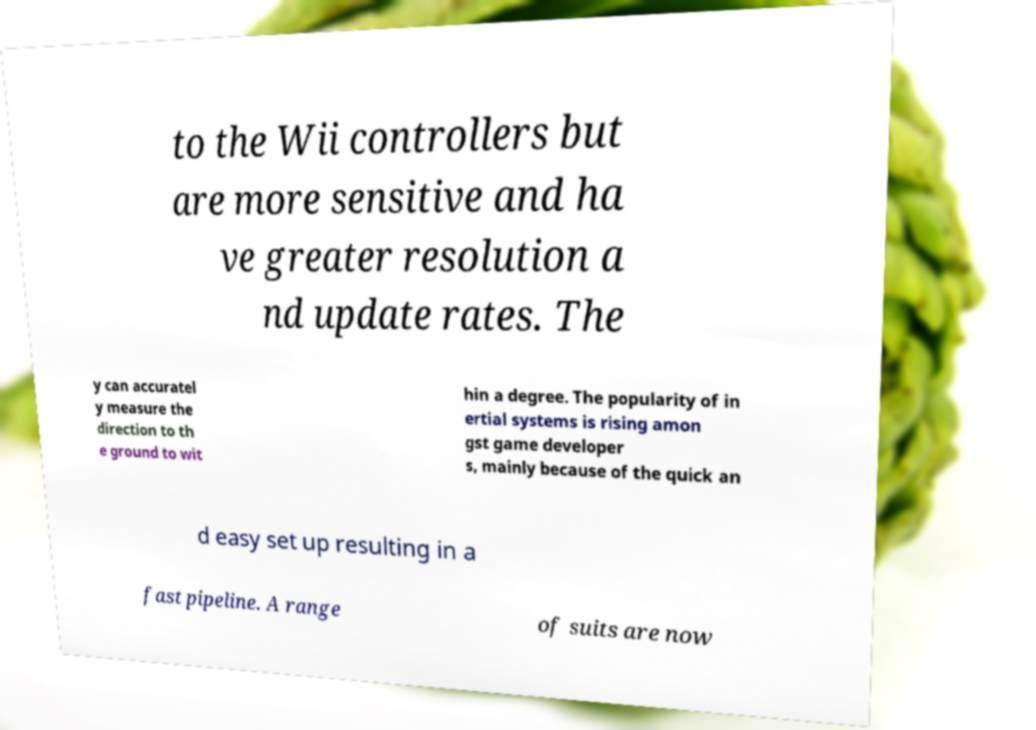Can you read and provide the text displayed in the image?This photo seems to have some interesting text. Can you extract and type it out for me? to the Wii controllers but are more sensitive and ha ve greater resolution a nd update rates. The y can accuratel y measure the direction to th e ground to wit hin a degree. The popularity of in ertial systems is rising amon gst game developer s, mainly because of the quick an d easy set up resulting in a fast pipeline. A range of suits are now 